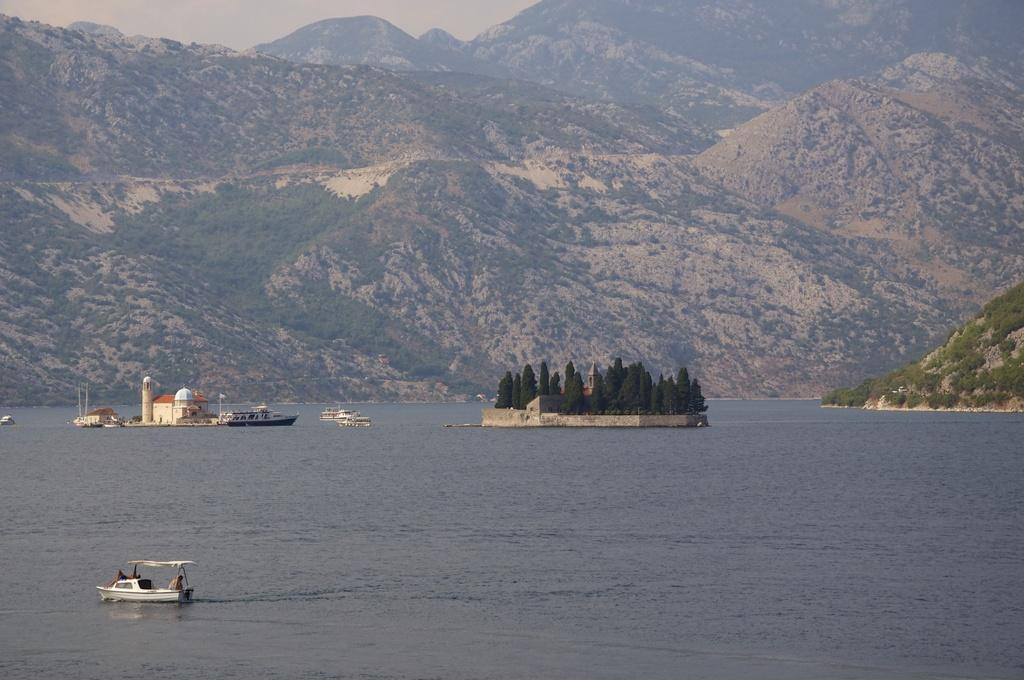What is on the water in the image? There are ships on the water in the image. What can be seen in the center of the image? There are trees in the center of the image. What structure is located on the left side of the image? There is a building on the left side of the image. What is visible in the background of the image? There are mountains visible in the background of the image. What type of argument is taking place between the ships in the image? There is no argument taking place between the ships in the image; they are simply on the water. How many apples are hanging from the trees in the image? There are no apples present in the image; it features ships, trees, a building, and mountains. 